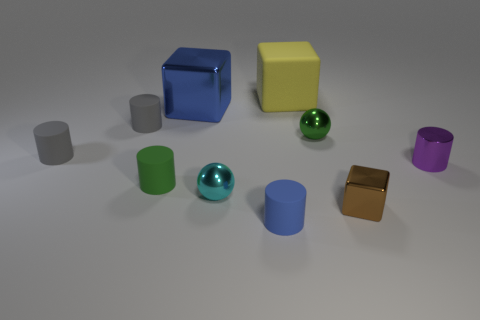What is the material of the blue thing that is right of the shiny cube that is to the left of the tiny blue matte cylinder?
Provide a succinct answer. Rubber. Are there more small cyan things in front of the green cylinder than gray cylinders that are in front of the small metallic block?
Offer a terse response. Yes. What size is the purple cylinder?
Provide a short and direct response. Small. There is a tiny matte object that is to the right of the cyan object; is it the same color as the large metallic object?
Offer a terse response. Yes. Is there a shiny thing that is behind the tiny green object that is behind the tiny purple metal object?
Provide a succinct answer. Yes. Is the number of tiny gray cylinders behind the green metal object less than the number of green cylinders that are right of the brown metal cube?
Ensure brevity in your answer.  No. What is the size of the blue thing behind the tiny purple thing to the right of the blue object that is in front of the big metallic thing?
Keep it short and to the point. Large. Do the block on the left side of the yellow block and the blue cylinder have the same size?
Your answer should be compact. No. How many other objects are the same material as the tiny blue cylinder?
Your response must be concise. 4. Is the number of tiny cylinders greater than the number of purple blocks?
Provide a short and direct response. Yes. 